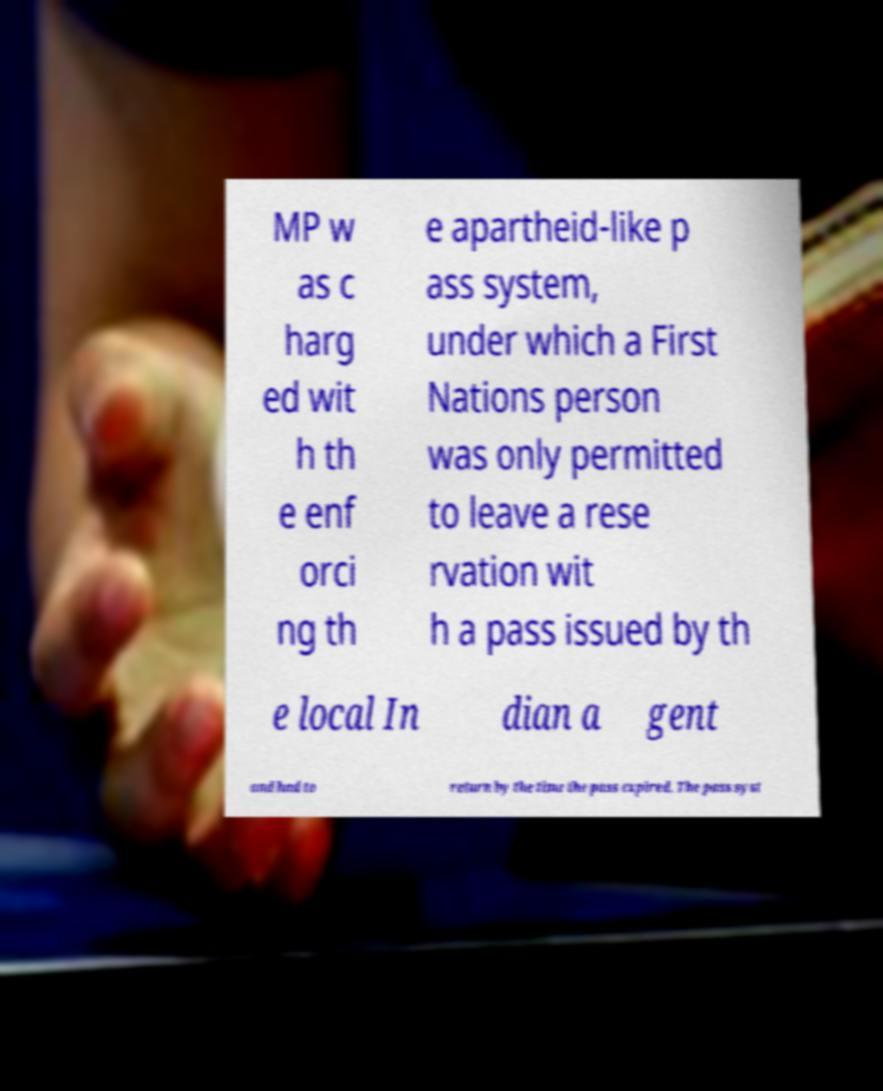For documentation purposes, I need the text within this image transcribed. Could you provide that? MP w as c harg ed wit h th e enf orci ng th e apartheid-like p ass system, under which a First Nations person was only permitted to leave a rese rvation wit h a pass issued by th e local In dian a gent and had to return by the time the pass expired. The pass syst 